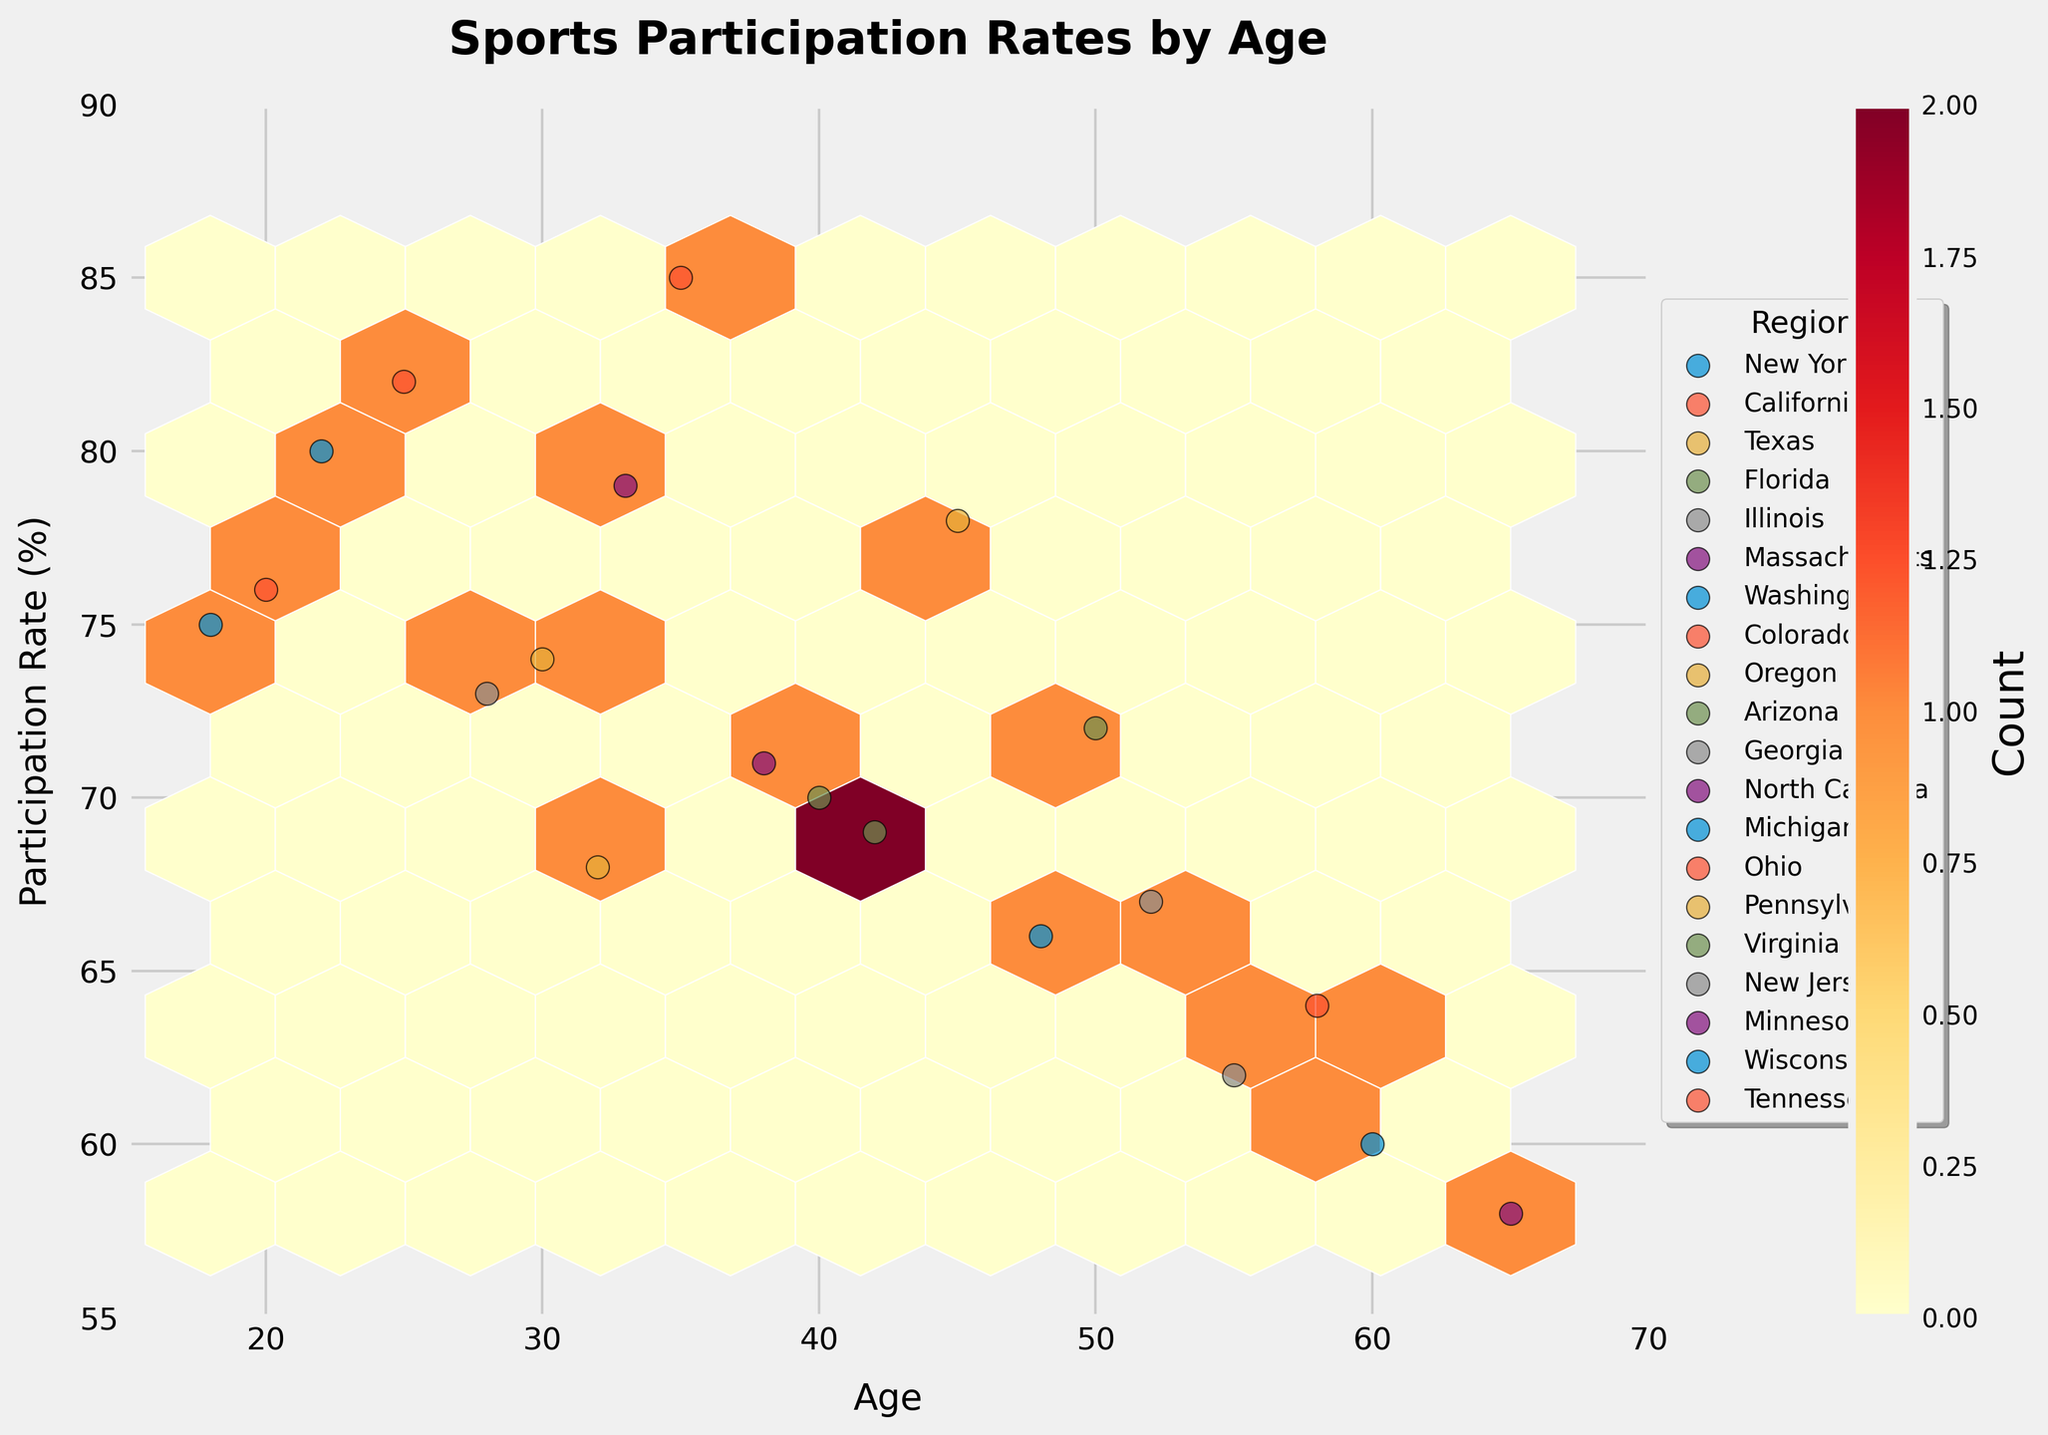what is the main focus of the plot? The title of the plot is 'Sports Participation Rates by Age', indicating that the main focus is on visualizing the participation rates in sports across different age groups.
Answer: Sports Participation Rates by Age What is the color theme used for the hexbin plot? The hexbin plot uses a color gradient ranging from light yellow to dark red.
Answer: Yellow to Red What are the axes labels of the hexbin plot? The x-axis is labeled 'Age', and the y-axis is labeled 'Participation Rate (%)'.
Answer: Age and Participation Rate (%) What age and participation rate do most data points cluster around? Looking at the color density (the darkest regions of the hexbin plot), most data points cluster around the ages 30 to 35 and participation rates of 70% to 75%.
Answer: 30 to 35 years and 70% to 75% How many geographic regions are represented in the scatter plot overlay? Each region has a unique marker represented in the scatter plot. Counting the different markers and verifying with the legend, there are 20 geographic regions represented.
Answer: 20 regions Which age group has the highest participation rate? Observing the data points, the age group of 35 (represented by a marker) in Colorado has the highest participation rate of 85%.
Answer: Age 35, Colorado, 85% Which age group has the lowest participation rate? Observing the data points, the age group of 65 (represented by a marker) in Massachusetts has the lowest participation rate of 58%.
Answer: Age 65, Massachusetts, 58% Is there a correlation between age and participation rate in the plot? The plot shows that as age increases, the participation rate generally decreases. This indicates a negative correlation.
Answer: Negative correlation In which age group and region does the participation rate approximately match the midpoint of the range (72.5%)? Evaluating the data points, the age group of 50 in Arizona has a participation rate of 72%, which is close to the midpoint of 72.5%.
Answer: Age 50, Arizona, 72% How does the participation rate of a 20-year-old compare to a 60-year-old? The participation rate of a 20-year-old in Ohio is 76%, while a 60-year-old in Michigan has a participation rate of 60%. Comparing these, the participation rate is higher for the 20-year-old.
Answer: 20-year-old, 76% vs. 60-year-old, 60% 